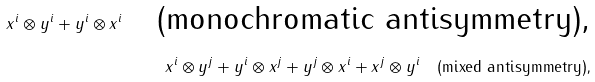Convert formula to latex. <formula><loc_0><loc_0><loc_500><loc_500>x ^ { i } \otimes y ^ { i } + y ^ { i } \otimes x ^ { i } \quad \text {(monochromatic antisymmetry),} \\ x ^ { i } \otimes y ^ { j } + y ^ { i } \otimes x ^ { j } + y ^ { j } \otimes x ^ { i } + x ^ { j } \otimes y ^ { i } \quad \text {(mixed antisymmetry),}</formula> 